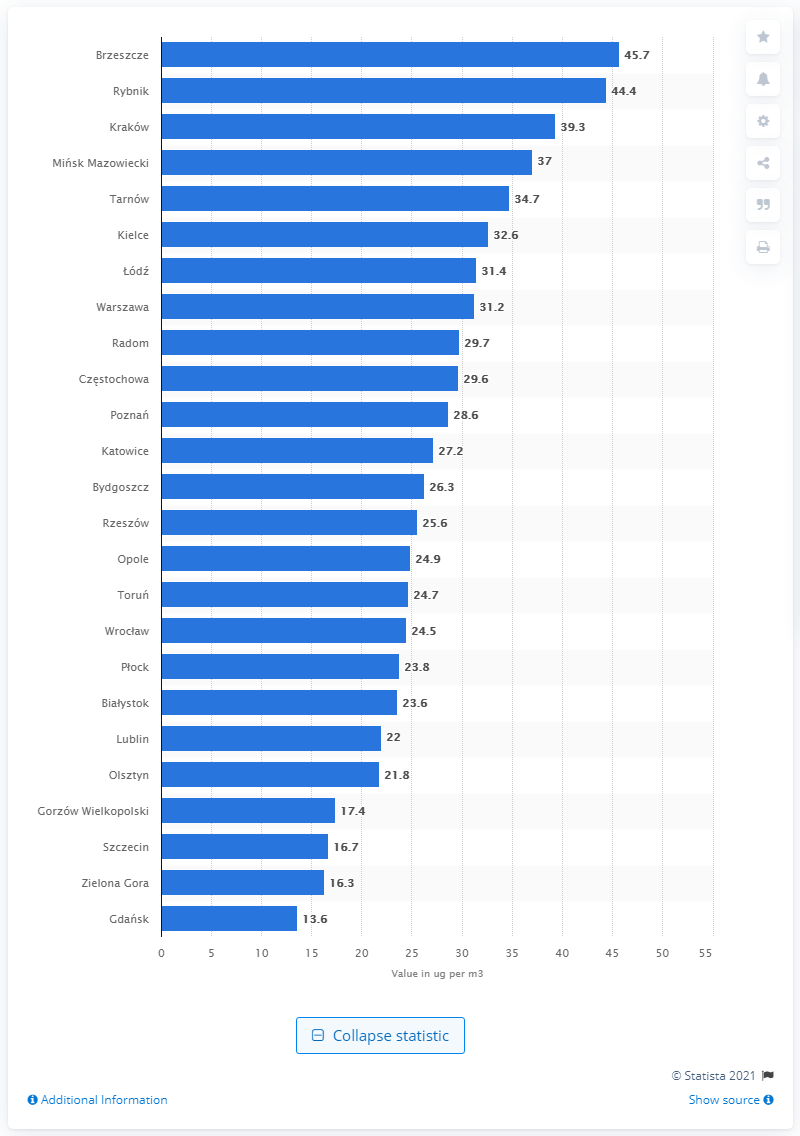Identify some key points in this picture. The city with the highest annual average concentration of P10 particulates in Poland in 2020 was Brzeszcze. 